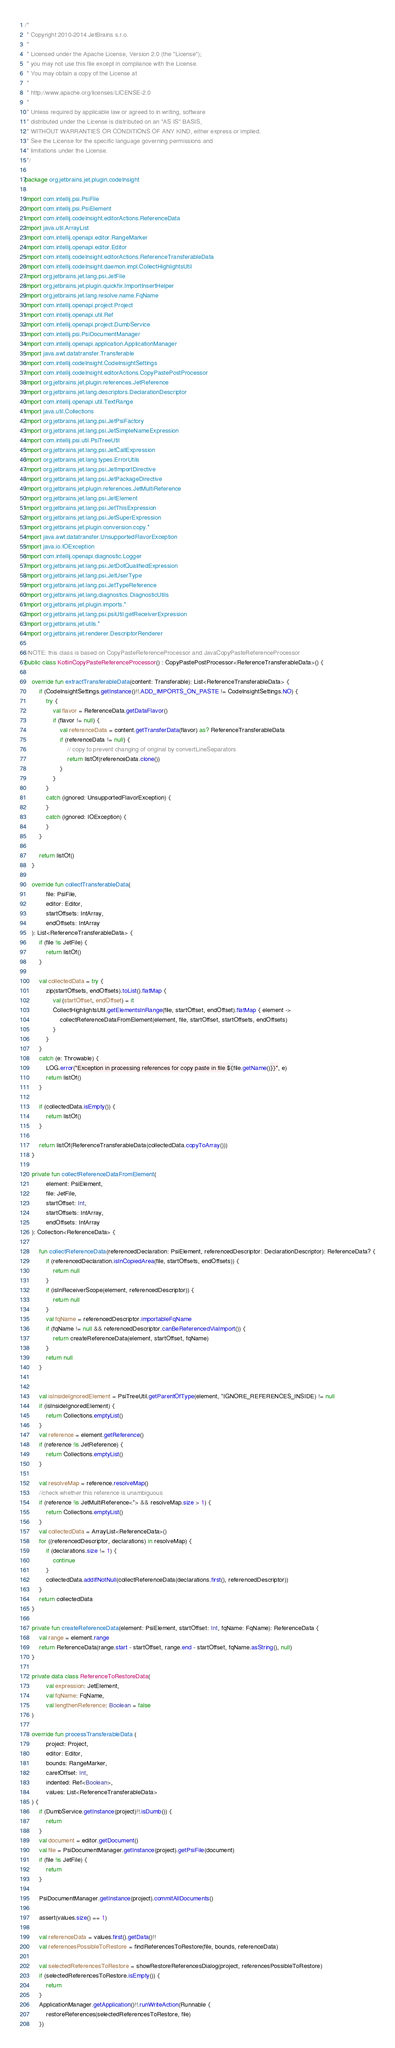<code> <loc_0><loc_0><loc_500><loc_500><_Kotlin_>/*
 * Copyright 2010-2014 JetBrains s.r.o.
 *
 * Licensed under the Apache License, Version 2.0 (the "License");
 * you may not use this file except in compliance with the License.
 * You may obtain a copy of the License at
 *
 * http://www.apache.org/licenses/LICENSE-2.0
 *
 * Unless required by applicable law or agreed to in writing, software
 * distributed under the License is distributed on an "AS IS" BASIS,
 * WITHOUT WARRANTIES OR CONDITIONS OF ANY KIND, either express or implied.
 * See the License for the specific language governing permissions and
 * limitations under the License.
 */

package org.jetbrains.jet.plugin.codeInsight

import com.intellij.psi.PsiFile
import com.intellij.psi.PsiElement
import com.intellij.codeInsight.editorActions.ReferenceData
import java.util.ArrayList
import com.intellij.openapi.editor.RangeMarker
import com.intellij.openapi.editor.Editor
import com.intellij.codeInsight.editorActions.ReferenceTransferableData
import com.intellij.codeInsight.daemon.impl.CollectHighlightsUtil
import org.jetbrains.jet.lang.psi.JetFile
import org.jetbrains.jet.plugin.quickfix.ImportInsertHelper
import org.jetbrains.jet.lang.resolve.name.FqName
import com.intellij.openapi.project.Project
import com.intellij.openapi.util.Ref
import com.intellij.openapi.project.DumbService
import com.intellij.psi.PsiDocumentManager
import com.intellij.openapi.application.ApplicationManager
import java.awt.datatransfer.Transferable
import com.intellij.codeInsight.CodeInsightSettings
import com.intellij.codeInsight.editorActions.CopyPastePostProcessor
import org.jetbrains.jet.plugin.references.JetReference
import org.jetbrains.jet.lang.descriptors.DeclarationDescriptor
import com.intellij.openapi.util.TextRange
import java.util.Collections
import org.jetbrains.jet.lang.psi.JetPsiFactory
import org.jetbrains.jet.lang.psi.JetSimpleNameExpression
import com.intellij.psi.util.PsiTreeUtil
import org.jetbrains.jet.lang.psi.JetCallExpression
import org.jetbrains.jet.lang.types.ErrorUtils
import org.jetbrains.jet.lang.psi.JetImportDirective
import org.jetbrains.jet.lang.psi.JetPackageDirective
import org.jetbrains.jet.plugin.references.JetMultiReference
import org.jetbrains.jet.lang.psi.JetElement
import org.jetbrains.jet.lang.psi.JetThisExpression
import org.jetbrains.jet.lang.psi.JetSuperExpression
import org.jetbrains.jet.plugin.conversion.copy.*
import java.awt.datatransfer.UnsupportedFlavorException
import java.io.IOException
import com.intellij.openapi.diagnostic.Logger
import org.jetbrains.jet.lang.psi.JetDotQualifiedExpression
import org.jetbrains.jet.lang.psi.JetUserType
import org.jetbrains.jet.lang.psi.JetTypeReference
import org.jetbrains.jet.lang.diagnostics.DiagnosticUtils
import org.jetbrains.jet.plugin.imports.*
import org.jetbrains.jet.lang.psi.psiUtil.getReceiverExpression
import org.jetbrains.jet.utils.*
import org.jetbrains.jet.renderer.DescriptorRenderer

//NOTE: this class is based on CopyPasteReferenceProcessor and JavaCopyPasteReferenceProcessor
public class KotlinCopyPasteReferenceProcessor() : CopyPastePostProcessor<ReferenceTransferableData>() {

    override fun extractTransferableData(content: Transferable): List<ReferenceTransferableData> {
        if (CodeInsightSettings.getInstance()!!.ADD_IMPORTS_ON_PASTE != CodeInsightSettings.NO) {
            try {
                val flavor = ReferenceData.getDataFlavor()
                if (flavor != null) {
                    val referenceData = content.getTransferData(flavor) as? ReferenceTransferableData
                    if (referenceData != null) {
                        // copy to prevent changing of original by convertLineSeparators
                        return listOf(referenceData.clone())
                    }
                }
            }
            catch (ignored: UnsupportedFlavorException) {
            }
            catch (ignored: IOException) {
            }
        }

        return listOf()
    }

    override fun collectTransferableData(
            file: PsiFile,
            editor: Editor,
            startOffsets: IntArray,
            endOffsets: IntArray
    ): List<ReferenceTransferableData> {
        if (file !is JetFile) {
            return listOf()
        }

        val collectedData = try {
            zip(startOffsets, endOffsets).toList().flatMap {
                val (startOffset, endOffset) = it
                CollectHighlightsUtil.getElementsInRange(file, startOffset, endOffset).flatMap { element ->
                    collectReferenceDataFromElement(element, file, startOffset, startOffsets, endOffsets)
                }
            }
        }
        catch (e: Throwable) {
            LOG.error("Exception in processing references for copy paste in file ${file.getName()}}", e)
            return listOf()
        }

        if (collectedData.isEmpty()) {
            return listOf()
        }

        return listOf(ReferenceTransferableData(collectedData.copyToArray()))
    }

    private fun collectReferenceDataFromElement(
            element: PsiElement,
            file: JetFile,
            startOffset: Int,
            startOffsets: IntArray,
            endOffsets: IntArray
    ): Collection<ReferenceData> {

        fun collectReferenceData(referencedDeclaration: PsiElement, referencedDescriptor: DeclarationDescriptor): ReferenceData? {
            if (referencedDeclaration.isInCopiedArea(file, startOffsets, endOffsets)) {
                return null
            }
            if (isInReceiverScope(element, referencedDescriptor)) {
                return null
            }
            val fqName = referencedDescriptor.importableFqName
            if (fqName != null && referencedDescriptor.canBeReferencedViaImport()) {
                return createReferenceData(element, startOffset, fqName)
            }
            return null
        }


        val isInsideIgnoredElement = PsiTreeUtil.getParentOfType(element, *IGNORE_REFERENCES_INSIDE) != null
        if (isInsideIgnoredElement) {
            return Collections.emptyList()
        }
        val reference = element.getReference()
        if (reference !is JetReference) {
            return Collections.emptyList()
        }

        val resolveMap = reference.resolveMap()
        //check whether this reference is unambiguous
        if (reference !is JetMultiReference<*> && resolveMap.size > 1) {
            return Collections.emptyList()
        }
        val collectedData = ArrayList<ReferenceData>()
        for ((referencedDescriptor, declarations) in resolveMap) {
            if (declarations.size != 1) {
                continue
            }
            collectedData.addIfNotNull(collectReferenceData(declarations.first(), referencedDescriptor))
        }
        return collectedData
    }

    private fun createReferenceData(element: PsiElement, startOffset: Int, fqName: FqName): ReferenceData {
        val range = element.range
        return ReferenceData(range.start - startOffset, range.end - startOffset, fqName.asString(), null)
    }

    private data class ReferenceToRestoreData(
            val expression: JetElement,
            val fqName: FqName,
            val lengthenReference: Boolean = false
    )

    override fun processTransferableData (
            project: Project,
            editor: Editor,
            bounds: RangeMarker,
            caretOffset: Int,
            indented: Ref<Boolean>,
            values: List<ReferenceTransferableData>
    ) {
        if (DumbService.getInstance(project)!!.isDumb()) {
            return
        }
        val document = editor.getDocument()
        val file = PsiDocumentManager.getInstance(project).getPsiFile(document)
        if (file !is JetFile) {
            return
        }

        PsiDocumentManager.getInstance(project).commitAllDocuments()

        assert(values.size() == 1)

        val referenceData = values.first().getData()!!
        val referencesPossibleToRestore = findReferencesToRestore(file, bounds, referenceData)

        val selectedReferencesToRestore = showRestoreReferencesDialog(project, referencesPossibleToRestore)
        if (selectedReferencesToRestore.isEmpty()) {
            return
        }
        ApplicationManager.getApplication()!!.runWriteAction(Runnable {
            restoreReferences(selectedReferencesToRestore, file)
        })</code> 